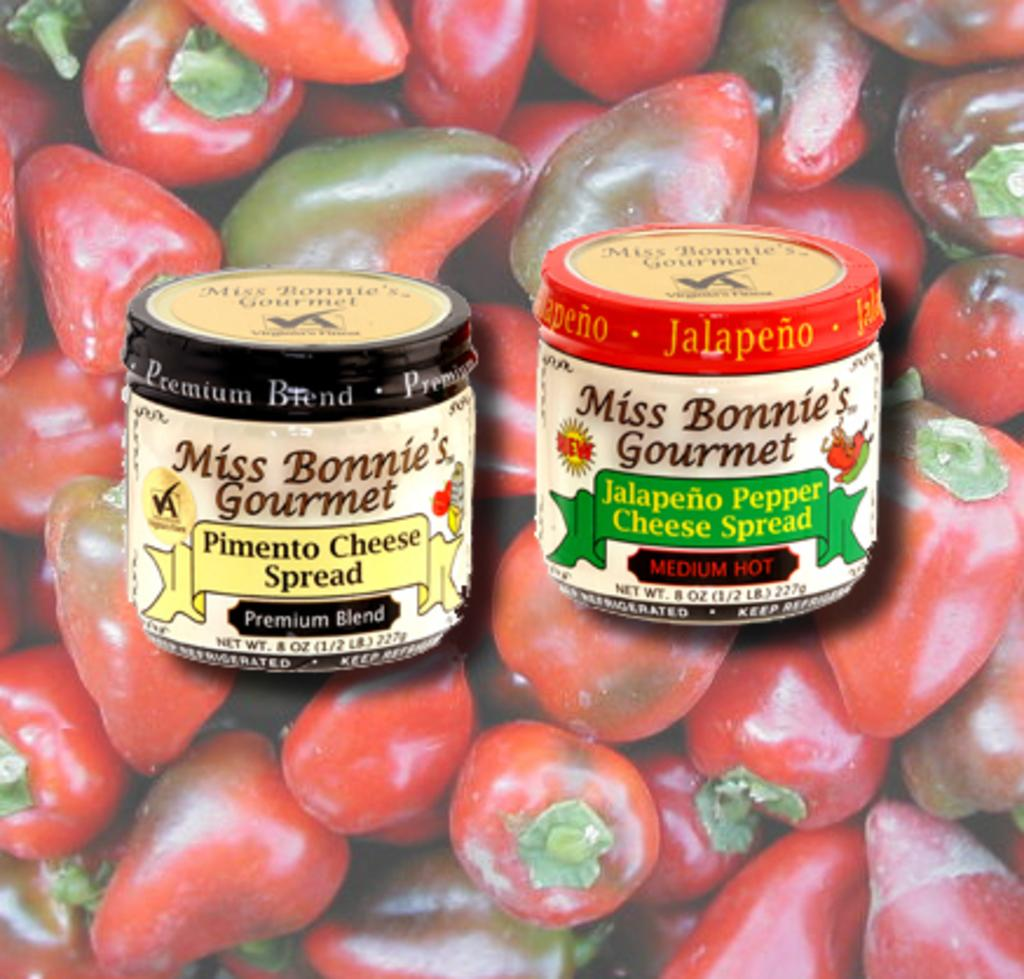How many objects are present in the image? There are two objects in the image. Can you describe the objects in the image? Unfortunately, the facts provided do not give enough information to describe the objects in the image. What can be seen in the background of the image? There are chillies in the background of the image. Is there a spy hiding among the chillies in the image? There is no mention of a spy or any hidden objects in the image. The facts provided only mention the presence of chillies in the background. 